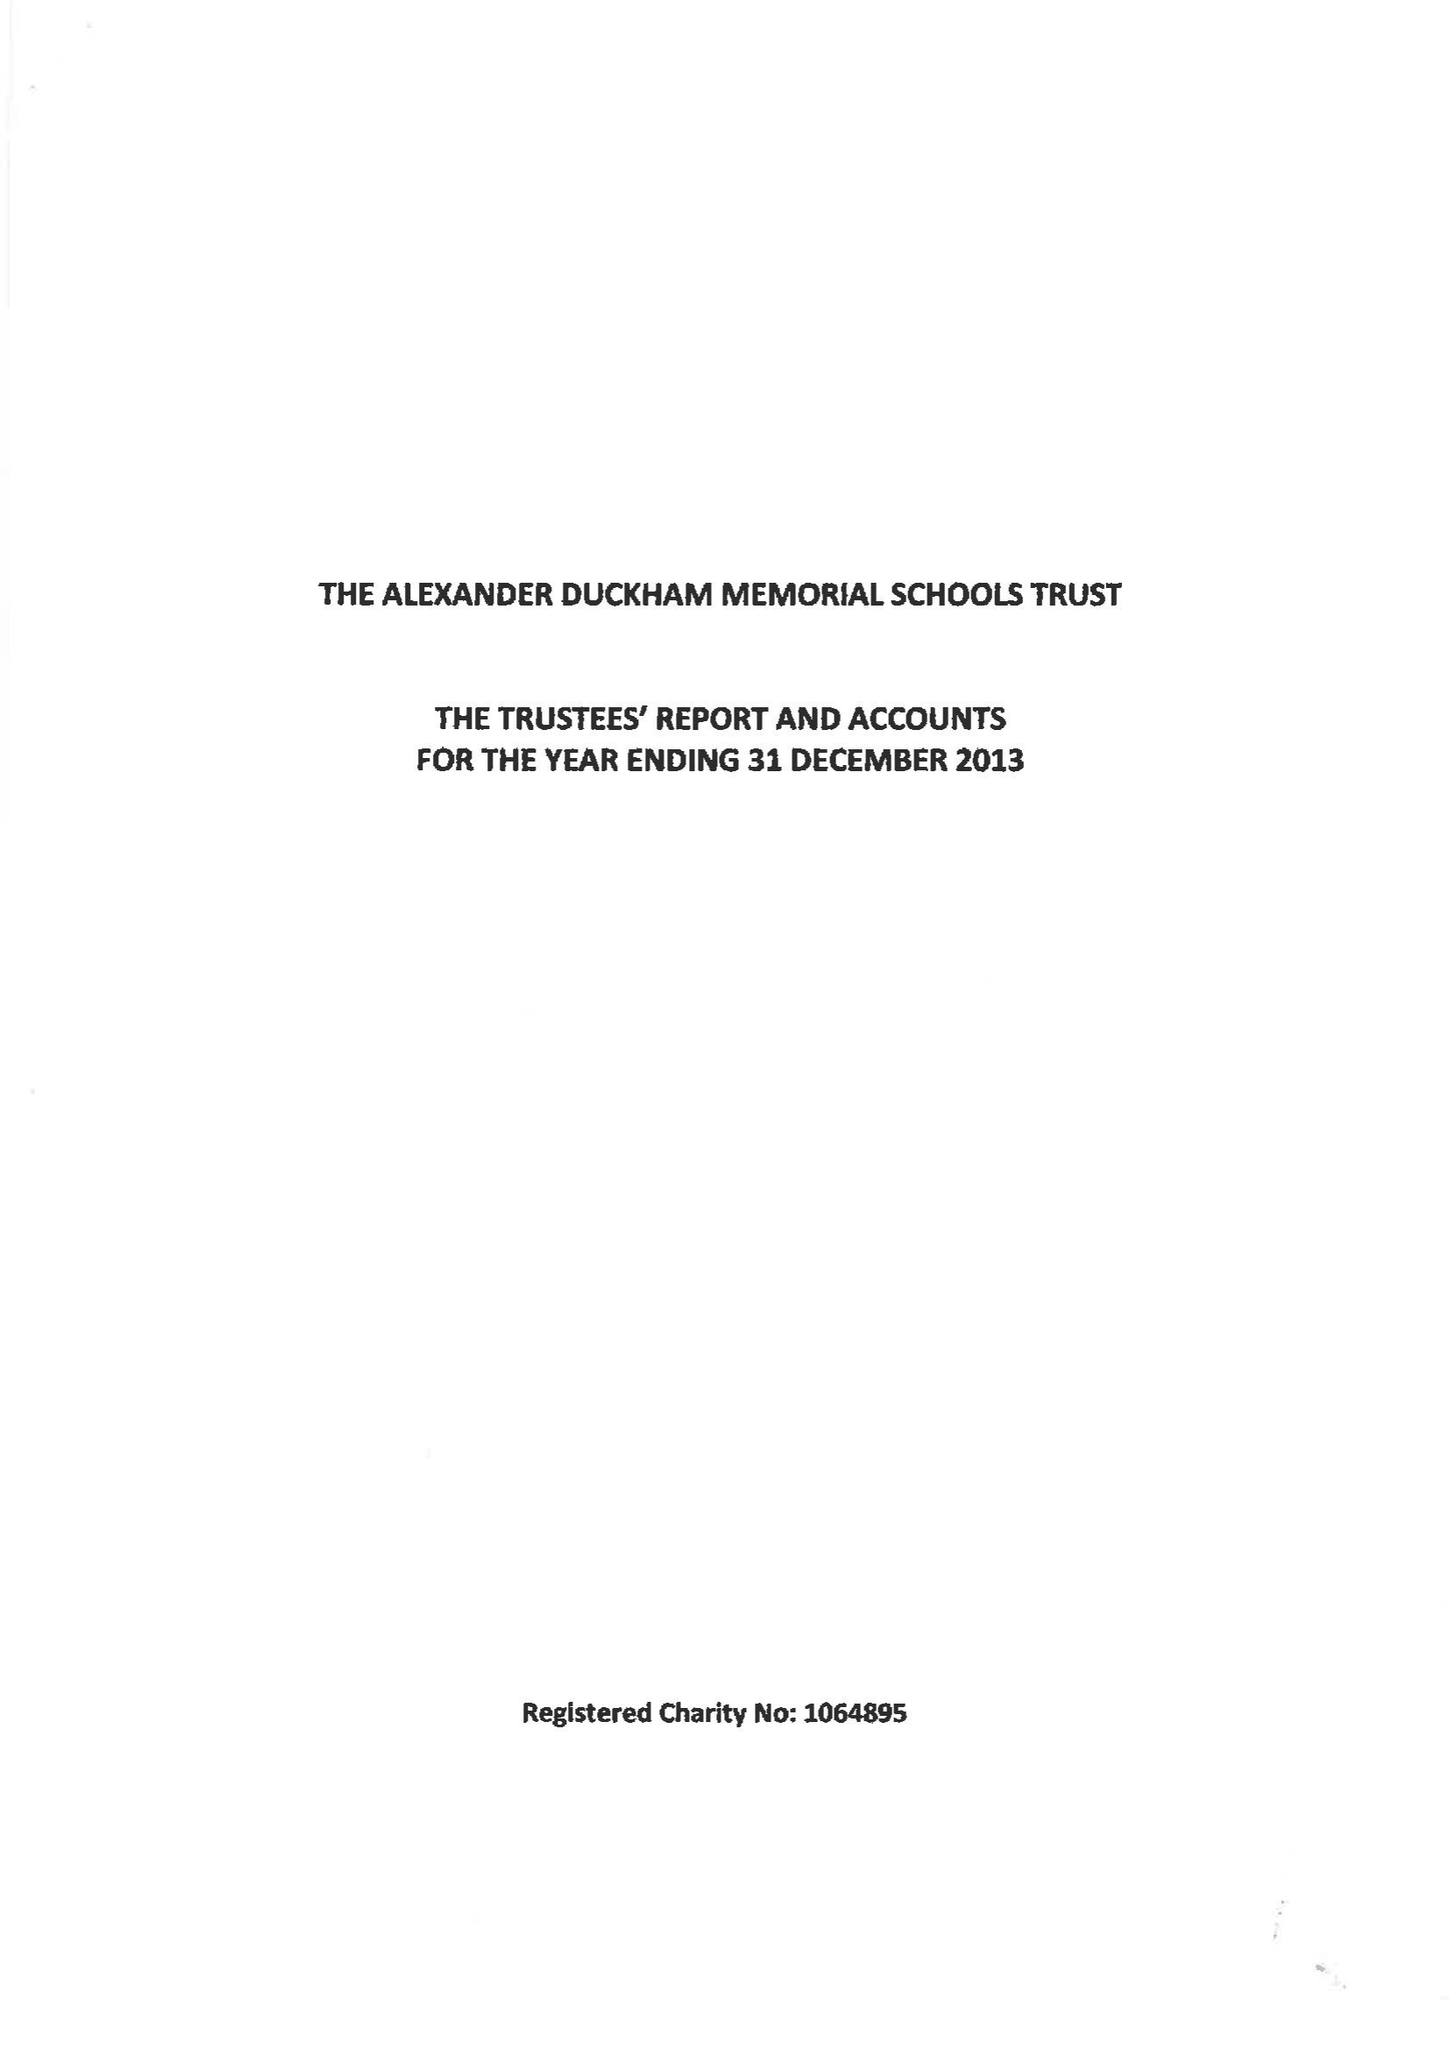What is the value for the charity_name?
Answer the question using a single word or phrase. The Alexander Duckham Memorial Schools Trust 